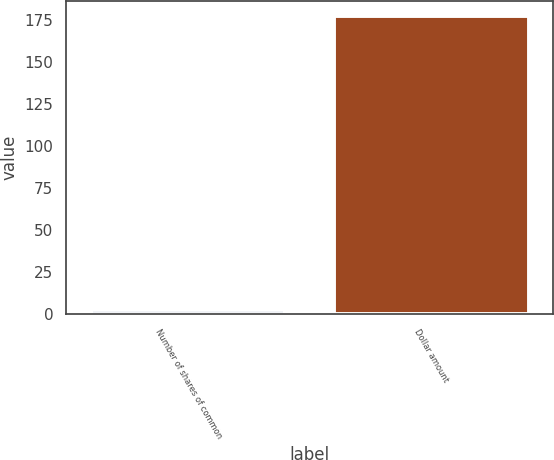Convert chart. <chart><loc_0><loc_0><loc_500><loc_500><bar_chart><fcel>Number of shares of common<fcel>Dollar amount<nl><fcel>2.7<fcel>177.4<nl></chart> 